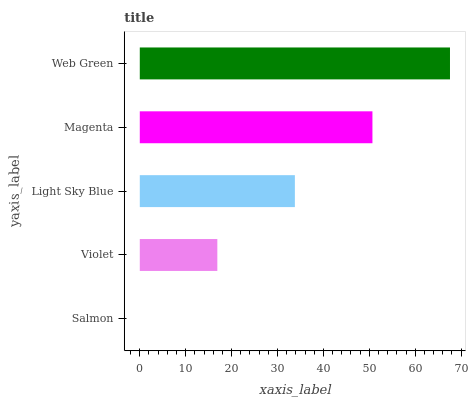Is Salmon the minimum?
Answer yes or no. Yes. Is Web Green the maximum?
Answer yes or no. Yes. Is Violet the minimum?
Answer yes or no. No. Is Violet the maximum?
Answer yes or no. No. Is Violet greater than Salmon?
Answer yes or no. Yes. Is Salmon less than Violet?
Answer yes or no. Yes. Is Salmon greater than Violet?
Answer yes or no. No. Is Violet less than Salmon?
Answer yes or no. No. Is Light Sky Blue the high median?
Answer yes or no. Yes. Is Light Sky Blue the low median?
Answer yes or no. Yes. Is Violet the high median?
Answer yes or no. No. Is Magenta the low median?
Answer yes or no. No. 